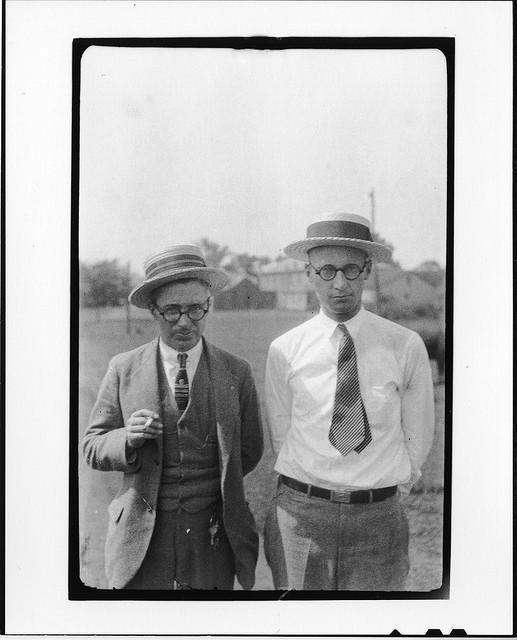How many people are wearing hats?
Give a very brief answer. 2. How many pictures?
Give a very brief answer. 1. How many people can you see?
Give a very brief answer. 2. 